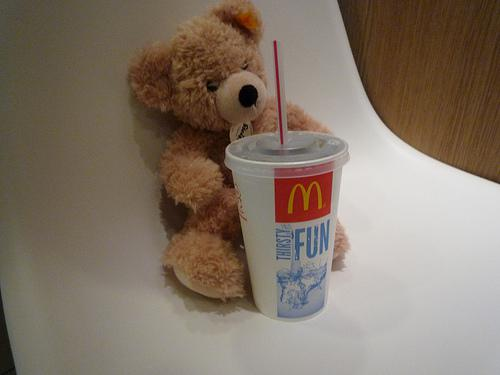Question: what restaurant is the cup from?
Choices:
A. Wendy's.
B. The steak house that is around the corner.
C. Fast food place that sells sandwiches.
D. McDonald's.
Answer with the letter. Answer: D Question: what pattern is on the straw?
Choices:
A. It's solid red.
B. Little stars.
C. Polka dots.
D. Stripes.
Answer with the letter. Answer: D Question: how can a person identify the restaurant?
Choices:
A. The logo.
B. The name.
C. The sign.
D. The ad on TV.
Answer with the letter. Answer: A Question: what is the logo for this restaurant?
Choices:
A. The buffalo.
B. The golden arches.
C. The shrimp.
D. The face of a little girl with pony tails.
Answer with the letter. Answer: B Question: what color is the bear's nose?
Choices:
A. Brown.
B. Red.
C. Gray.
D. Black.
Answer with the letter. Answer: D 